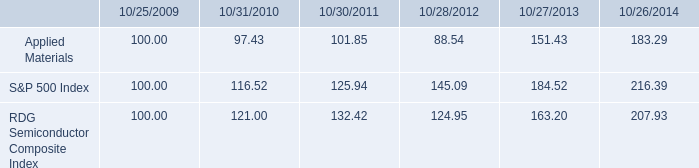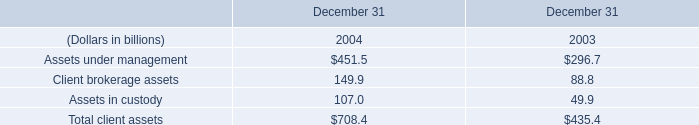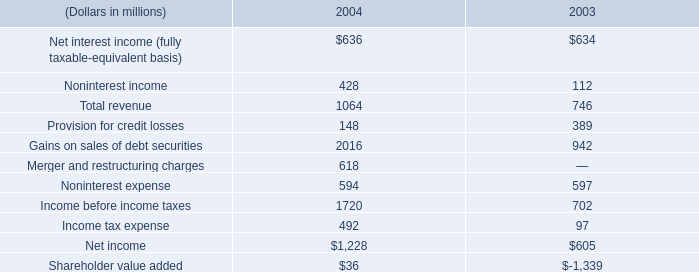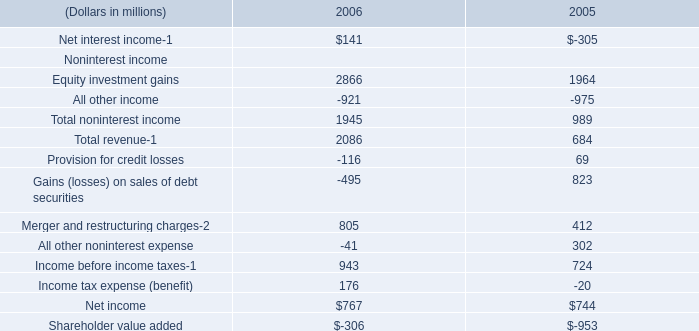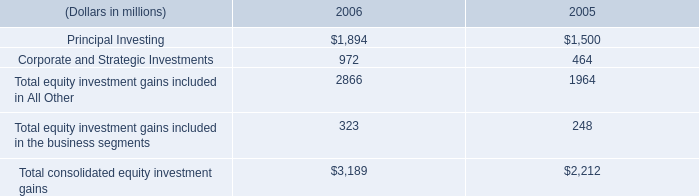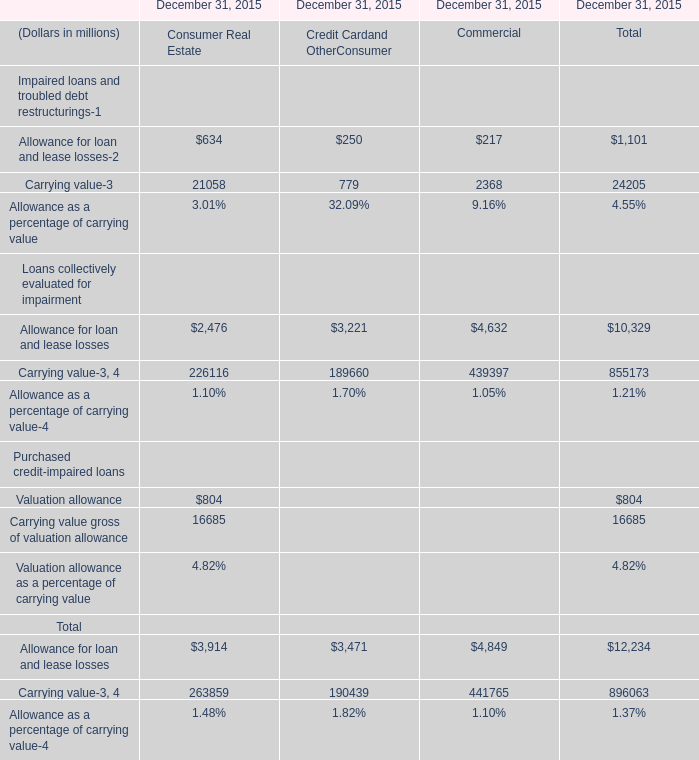how much more return was given for investing in the overall market rather than applied materials from 2009 to 2014 ? ( in a percentage ) 
Computations: ((216.39 - 100) - (183.29 - 100))
Answer: 33.1. 